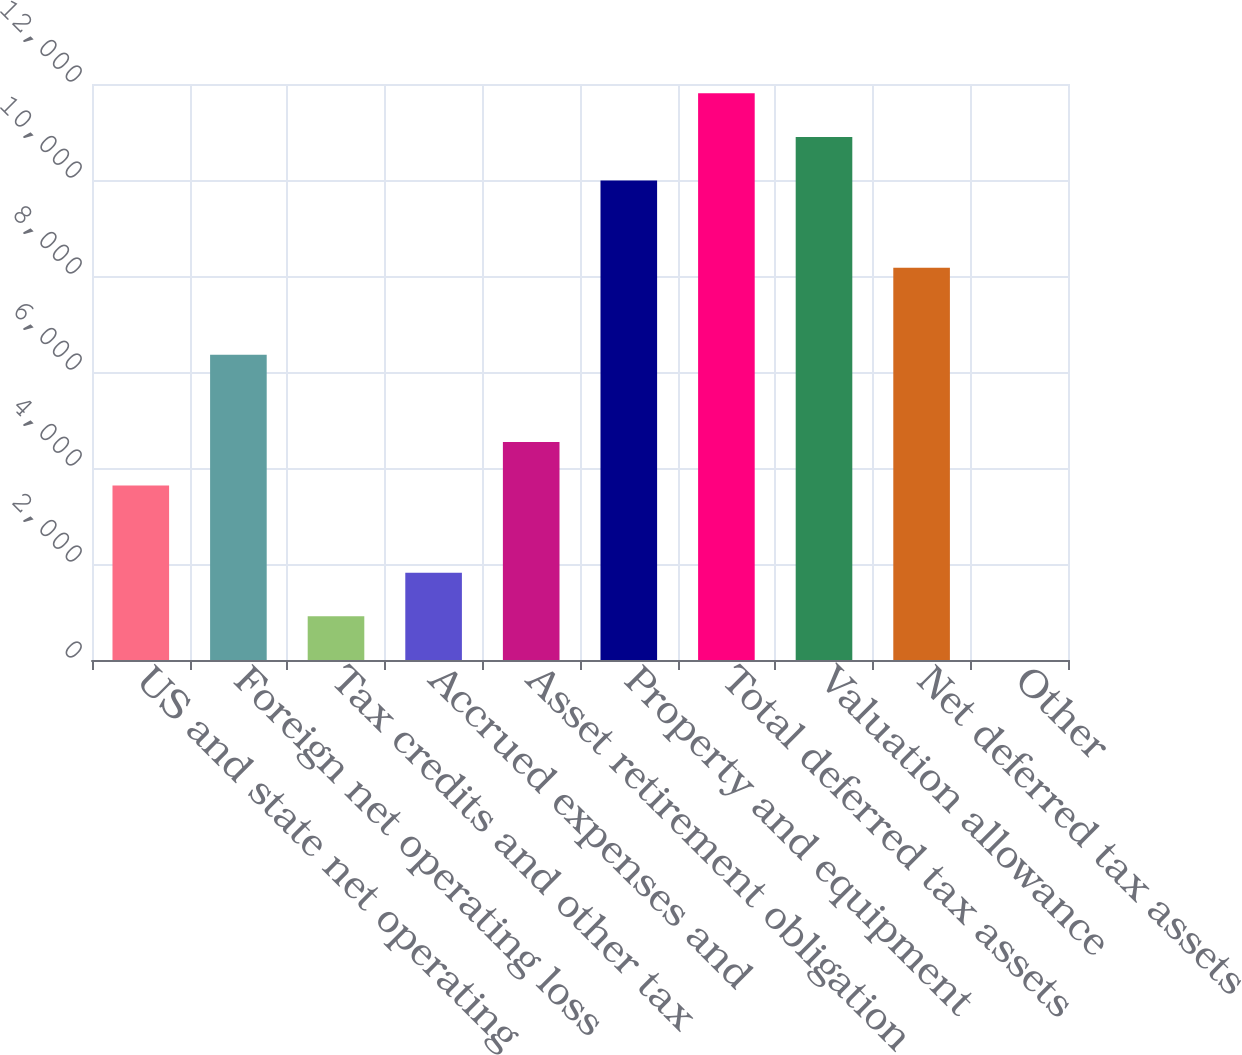Convert chart to OTSL. <chart><loc_0><loc_0><loc_500><loc_500><bar_chart><fcel>US and state net operating<fcel>Foreign net operating loss<fcel>Tax credits and other tax<fcel>Accrued expenses and<fcel>Asset retirement obligation<fcel>Property and equipment<fcel>Total deferred tax assets<fcel>Valuation allowance<fcel>Net deferred tax assets<fcel>Other<nl><fcel>3633<fcel>6357<fcel>909<fcel>1817<fcel>4541<fcel>9989<fcel>11805<fcel>10897<fcel>8173<fcel>1<nl></chart> 